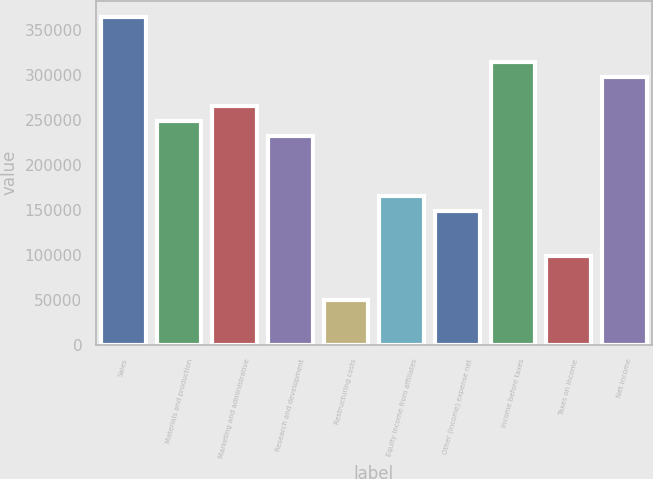Convert chart. <chart><loc_0><loc_0><loc_500><loc_500><bar_chart><fcel>Sales<fcel>Materials and production<fcel>Marketing and administrative<fcel>Research and development<fcel>Restructuring costs<fcel>Equity income from affiliates<fcel>Other (income) expense net<fcel>Income before taxes<fcel>Taxes on income<fcel>Net income<nl><fcel>364536<fcel>248548<fcel>265118<fcel>231979<fcel>49712.6<fcel>165700<fcel>149130<fcel>314827<fcel>99421.5<fcel>298257<nl></chart> 